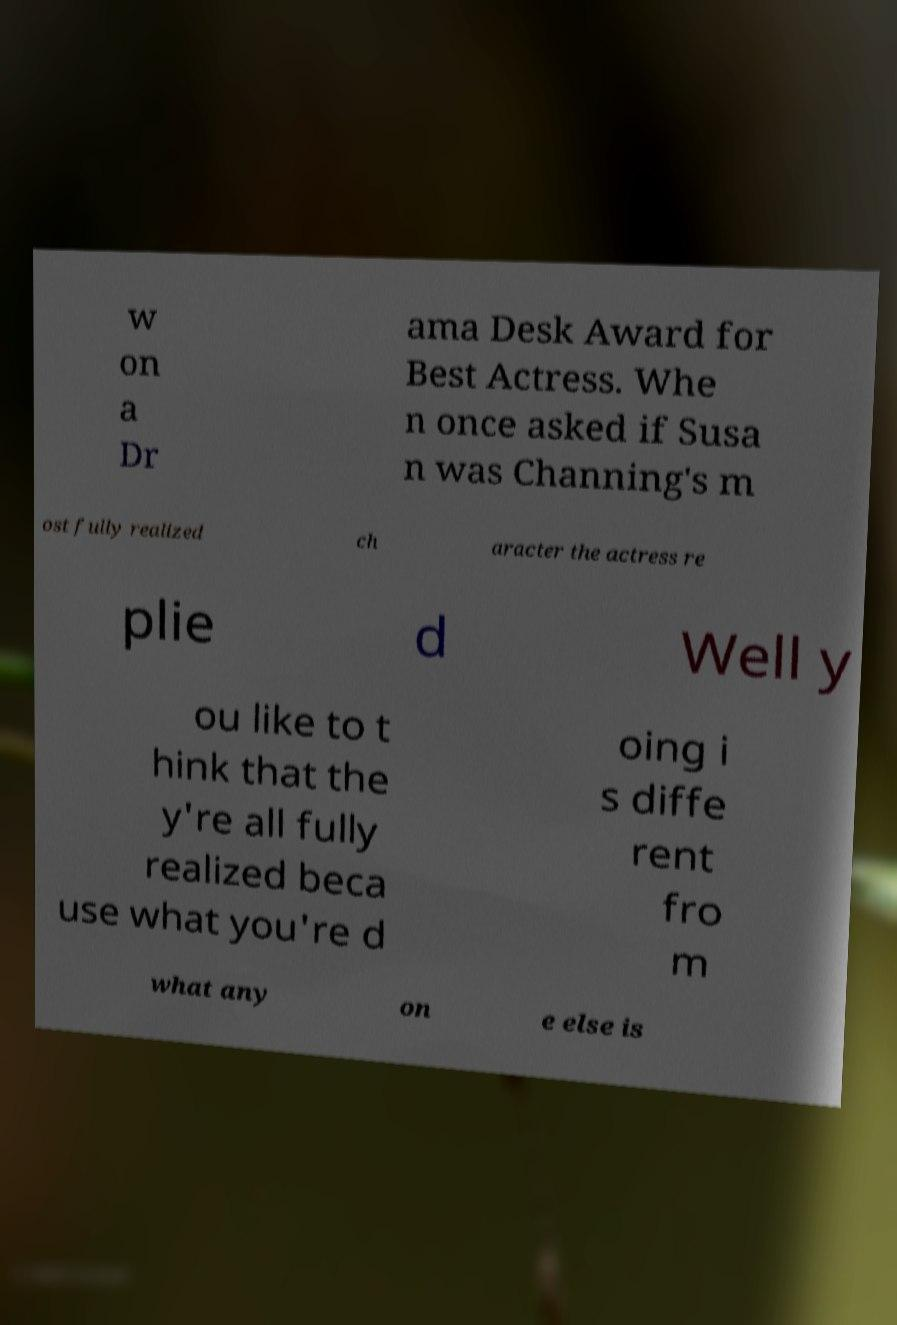Please read and relay the text visible in this image. What does it say? w on a Dr ama Desk Award for Best Actress. Whe n once asked if Susa n was Channing's m ost fully realized ch aracter the actress re plie d Well y ou like to t hink that the y're all fully realized beca use what you're d oing i s diffe rent fro m what any on e else is 